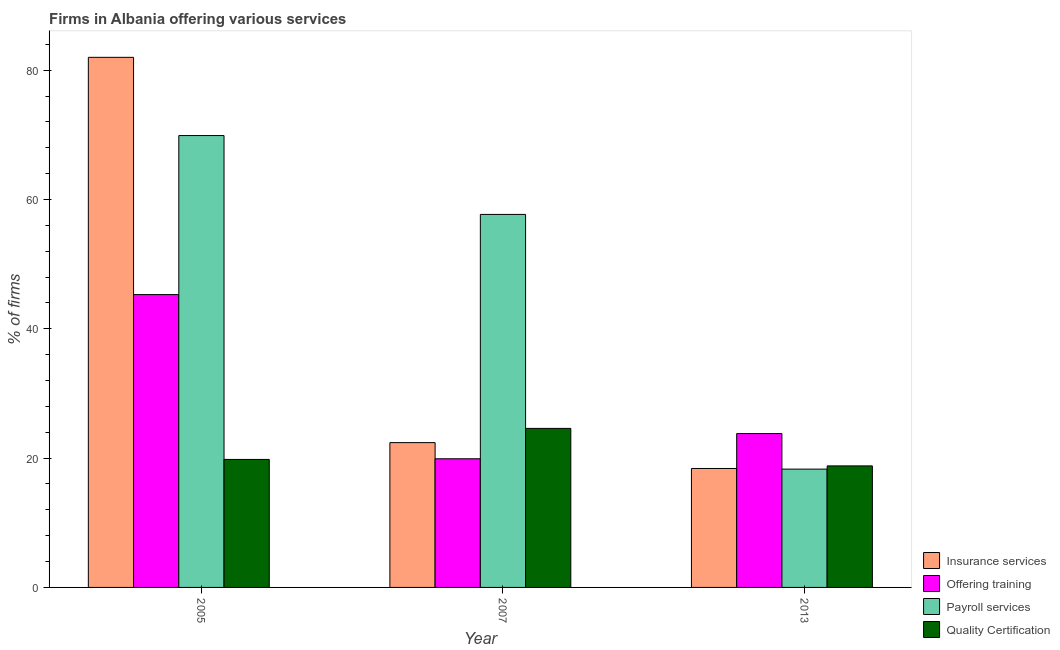How many different coloured bars are there?
Your response must be concise. 4. How many groups of bars are there?
Offer a very short reply. 3. Are the number of bars per tick equal to the number of legend labels?
Give a very brief answer. Yes. How many bars are there on the 2nd tick from the left?
Make the answer very short. 4. What is the label of the 2nd group of bars from the left?
Provide a short and direct response. 2007. In how many cases, is the number of bars for a given year not equal to the number of legend labels?
Make the answer very short. 0. What is the percentage of firms offering quality certification in 2013?
Keep it short and to the point. 18.8. Across all years, what is the maximum percentage of firms offering training?
Offer a very short reply. 45.3. Across all years, what is the minimum percentage of firms offering insurance services?
Provide a succinct answer. 18.4. In which year was the percentage of firms offering quality certification maximum?
Give a very brief answer. 2007. What is the total percentage of firms offering quality certification in the graph?
Ensure brevity in your answer.  63.2. What is the difference between the percentage of firms offering training in 2005 and that in 2007?
Your response must be concise. 25.4. What is the difference between the percentage of firms offering training in 2005 and the percentage of firms offering insurance services in 2007?
Keep it short and to the point. 25.4. What is the average percentage of firms offering payroll services per year?
Your answer should be very brief. 48.63. What is the ratio of the percentage of firms offering payroll services in 2007 to that in 2013?
Your response must be concise. 3.15. Is the difference between the percentage of firms offering insurance services in 2005 and 2013 greater than the difference between the percentage of firms offering quality certification in 2005 and 2013?
Offer a very short reply. No. What is the difference between the highest and the second highest percentage of firms offering training?
Provide a succinct answer. 21.5. What is the difference between the highest and the lowest percentage of firms offering quality certification?
Make the answer very short. 5.8. In how many years, is the percentage of firms offering training greater than the average percentage of firms offering training taken over all years?
Your answer should be very brief. 1. Is it the case that in every year, the sum of the percentage of firms offering payroll services and percentage of firms offering quality certification is greater than the sum of percentage of firms offering training and percentage of firms offering insurance services?
Your answer should be very brief. No. What does the 3rd bar from the left in 2005 represents?
Keep it short and to the point. Payroll services. What does the 4th bar from the right in 2013 represents?
Provide a short and direct response. Insurance services. Is it the case that in every year, the sum of the percentage of firms offering insurance services and percentage of firms offering training is greater than the percentage of firms offering payroll services?
Make the answer very short. No. How many bars are there?
Your answer should be compact. 12. Are all the bars in the graph horizontal?
Provide a succinct answer. No. How many years are there in the graph?
Give a very brief answer. 3. What is the difference between two consecutive major ticks on the Y-axis?
Your response must be concise. 20. Are the values on the major ticks of Y-axis written in scientific E-notation?
Provide a succinct answer. No. Does the graph contain any zero values?
Give a very brief answer. No. Where does the legend appear in the graph?
Make the answer very short. Bottom right. How many legend labels are there?
Ensure brevity in your answer.  4. How are the legend labels stacked?
Make the answer very short. Vertical. What is the title of the graph?
Offer a terse response. Firms in Albania offering various services . What is the label or title of the X-axis?
Ensure brevity in your answer.  Year. What is the label or title of the Y-axis?
Provide a short and direct response. % of firms. What is the % of firms of Insurance services in 2005?
Give a very brief answer. 82. What is the % of firms in Offering training in 2005?
Your answer should be very brief. 45.3. What is the % of firms of Payroll services in 2005?
Your answer should be very brief. 69.9. What is the % of firms of Quality Certification in 2005?
Offer a terse response. 19.8. What is the % of firms of Insurance services in 2007?
Keep it short and to the point. 22.4. What is the % of firms of Offering training in 2007?
Offer a terse response. 19.9. What is the % of firms in Payroll services in 2007?
Your answer should be very brief. 57.7. What is the % of firms of Quality Certification in 2007?
Your answer should be very brief. 24.6. What is the % of firms in Offering training in 2013?
Make the answer very short. 23.8. What is the % of firms in Quality Certification in 2013?
Offer a terse response. 18.8. Across all years, what is the maximum % of firms in Offering training?
Your response must be concise. 45.3. Across all years, what is the maximum % of firms in Payroll services?
Offer a terse response. 69.9. Across all years, what is the maximum % of firms in Quality Certification?
Make the answer very short. 24.6. Across all years, what is the minimum % of firms of Payroll services?
Offer a very short reply. 18.3. Across all years, what is the minimum % of firms of Quality Certification?
Your answer should be compact. 18.8. What is the total % of firms of Insurance services in the graph?
Keep it short and to the point. 122.8. What is the total % of firms in Offering training in the graph?
Your answer should be compact. 89. What is the total % of firms of Payroll services in the graph?
Your answer should be compact. 145.9. What is the total % of firms of Quality Certification in the graph?
Provide a succinct answer. 63.2. What is the difference between the % of firms of Insurance services in 2005 and that in 2007?
Provide a short and direct response. 59.6. What is the difference between the % of firms of Offering training in 2005 and that in 2007?
Your answer should be very brief. 25.4. What is the difference between the % of firms of Quality Certification in 2005 and that in 2007?
Give a very brief answer. -4.8. What is the difference between the % of firms of Insurance services in 2005 and that in 2013?
Your answer should be compact. 63.6. What is the difference between the % of firms in Payroll services in 2005 and that in 2013?
Keep it short and to the point. 51.6. What is the difference between the % of firms of Quality Certification in 2005 and that in 2013?
Provide a succinct answer. 1. What is the difference between the % of firms in Payroll services in 2007 and that in 2013?
Ensure brevity in your answer.  39.4. What is the difference between the % of firms in Insurance services in 2005 and the % of firms in Offering training in 2007?
Your answer should be compact. 62.1. What is the difference between the % of firms in Insurance services in 2005 and the % of firms in Payroll services in 2007?
Provide a short and direct response. 24.3. What is the difference between the % of firms in Insurance services in 2005 and the % of firms in Quality Certification in 2007?
Provide a short and direct response. 57.4. What is the difference between the % of firms of Offering training in 2005 and the % of firms of Payroll services in 2007?
Offer a terse response. -12.4. What is the difference between the % of firms of Offering training in 2005 and the % of firms of Quality Certification in 2007?
Provide a succinct answer. 20.7. What is the difference between the % of firms of Payroll services in 2005 and the % of firms of Quality Certification in 2007?
Keep it short and to the point. 45.3. What is the difference between the % of firms of Insurance services in 2005 and the % of firms of Offering training in 2013?
Your answer should be compact. 58.2. What is the difference between the % of firms of Insurance services in 2005 and the % of firms of Payroll services in 2013?
Offer a very short reply. 63.7. What is the difference between the % of firms in Insurance services in 2005 and the % of firms in Quality Certification in 2013?
Your answer should be very brief. 63.2. What is the difference between the % of firms of Offering training in 2005 and the % of firms of Payroll services in 2013?
Give a very brief answer. 27. What is the difference between the % of firms in Payroll services in 2005 and the % of firms in Quality Certification in 2013?
Offer a very short reply. 51.1. What is the difference between the % of firms in Insurance services in 2007 and the % of firms in Offering training in 2013?
Your answer should be compact. -1.4. What is the difference between the % of firms in Insurance services in 2007 and the % of firms in Payroll services in 2013?
Your response must be concise. 4.1. What is the difference between the % of firms in Offering training in 2007 and the % of firms in Payroll services in 2013?
Make the answer very short. 1.6. What is the difference between the % of firms in Payroll services in 2007 and the % of firms in Quality Certification in 2013?
Your answer should be very brief. 38.9. What is the average % of firms in Insurance services per year?
Provide a succinct answer. 40.93. What is the average % of firms of Offering training per year?
Offer a very short reply. 29.67. What is the average % of firms in Payroll services per year?
Your response must be concise. 48.63. What is the average % of firms of Quality Certification per year?
Offer a terse response. 21.07. In the year 2005, what is the difference between the % of firms in Insurance services and % of firms in Offering training?
Ensure brevity in your answer.  36.7. In the year 2005, what is the difference between the % of firms in Insurance services and % of firms in Quality Certification?
Give a very brief answer. 62.2. In the year 2005, what is the difference between the % of firms in Offering training and % of firms in Payroll services?
Ensure brevity in your answer.  -24.6. In the year 2005, what is the difference between the % of firms in Payroll services and % of firms in Quality Certification?
Make the answer very short. 50.1. In the year 2007, what is the difference between the % of firms of Insurance services and % of firms of Offering training?
Offer a terse response. 2.5. In the year 2007, what is the difference between the % of firms of Insurance services and % of firms of Payroll services?
Provide a short and direct response. -35.3. In the year 2007, what is the difference between the % of firms in Insurance services and % of firms in Quality Certification?
Provide a succinct answer. -2.2. In the year 2007, what is the difference between the % of firms of Offering training and % of firms of Payroll services?
Ensure brevity in your answer.  -37.8. In the year 2007, what is the difference between the % of firms in Payroll services and % of firms in Quality Certification?
Ensure brevity in your answer.  33.1. In the year 2013, what is the difference between the % of firms of Insurance services and % of firms of Offering training?
Give a very brief answer. -5.4. In the year 2013, what is the difference between the % of firms in Insurance services and % of firms in Payroll services?
Provide a short and direct response. 0.1. In the year 2013, what is the difference between the % of firms in Insurance services and % of firms in Quality Certification?
Make the answer very short. -0.4. In the year 2013, what is the difference between the % of firms in Offering training and % of firms in Quality Certification?
Provide a short and direct response. 5. In the year 2013, what is the difference between the % of firms of Payroll services and % of firms of Quality Certification?
Keep it short and to the point. -0.5. What is the ratio of the % of firms of Insurance services in 2005 to that in 2007?
Provide a succinct answer. 3.66. What is the ratio of the % of firms of Offering training in 2005 to that in 2007?
Make the answer very short. 2.28. What is the ratio of the % of firms of Payroll services in 2005 to that in 2007?
Provide a succinct answer. 1.21. What is the ratio of the % of firms of Quality Certification in 2005 to that in 2007?
Make the answer very short. 0.8. What is the ratio of the % of firms in Insurance services in 2005 to that in 2013?
Your response must be concise. 4.46. What is the ratio of the % of firms in Offering training in 2005 to that in 2013?
Your answer should be very brief. 1.9. What is the ratio of the % of firms of Payroll services in 2005 to that in 2013?
Offer a terse response. 3.82. What is the ratio of the % of firms in Quality Certification in 2005 to that in 2013?
Your response must be concise. 1.05. What is the ratio of the % of firms of Insurance services in 2007 to that in 2013?
Keep it short and to the point. 1.22. What is the ratio of the % of firms of Offering training in 2007 to that in 2013?
Keep it short and to the point. 0.84. What is the ratio of the % of firms in Payroll services in 2007 to that in 2013?
Offer a very short reply. 3.15. What is the ratio of the % of firms of Quality Certification in 2007 to that in 2013?
Offer a very short reply. 1.31. What is the difference between the highest and the second highest % of firms in Insurance services?
Your answer should be very brief. 59.6. What is the difference between the highest and the lowest % of firms of Insurance services?
Offer a very short reply. 63.6. What is the difference between the highest and the lowest % of firms in Offering training?
Offer a very short reply. 25.4. What is the difference between the highest and the lowest % of firms of Payroll services?
Ensure brevity in your answer.  51.6. 